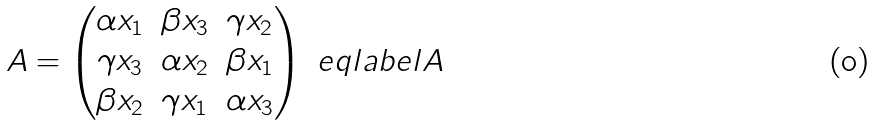Convert formula to latex. <formula><loc_0><loc_0><loc_500><loc_500>A = \begin{pmatrix} \alpha x _ { 1 } & \beta x _ { 3 } & \gamma x _ { 2 } \\ \gamma x _ { 3 } & \alpha x _ { 2 } & \beta x _ { 1 } \\ \beta x _ { 2 } & \gamma x _ { 1 } & \alpha x _ { 3 } \end{pmatrix} \ e q l a b e l { A }</formula> 